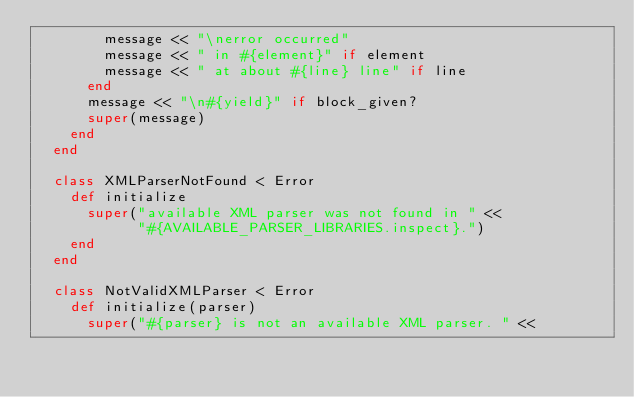<code> <loc_0><loc_0><loc_500><loc_500><_Ruby_>        message << "\nerror occurred"
        message << " in #{element}" if element
        message << " at about #{line} line" if line
      end
      message << "\n#{yield}" if block_given?
      super(message)
    end
  end

  class XMLParserNotFound < Error
    def initialize
      super("available XML parser was not found in " <<
            "#{AVAILABLE_PARSER_LIBRARIES.inspect}.")
    end
  end

  class NotValidXMLParser < Error
    def initialize(parser)
      super("#{parser} is not an available XML parser. " <<</code> 